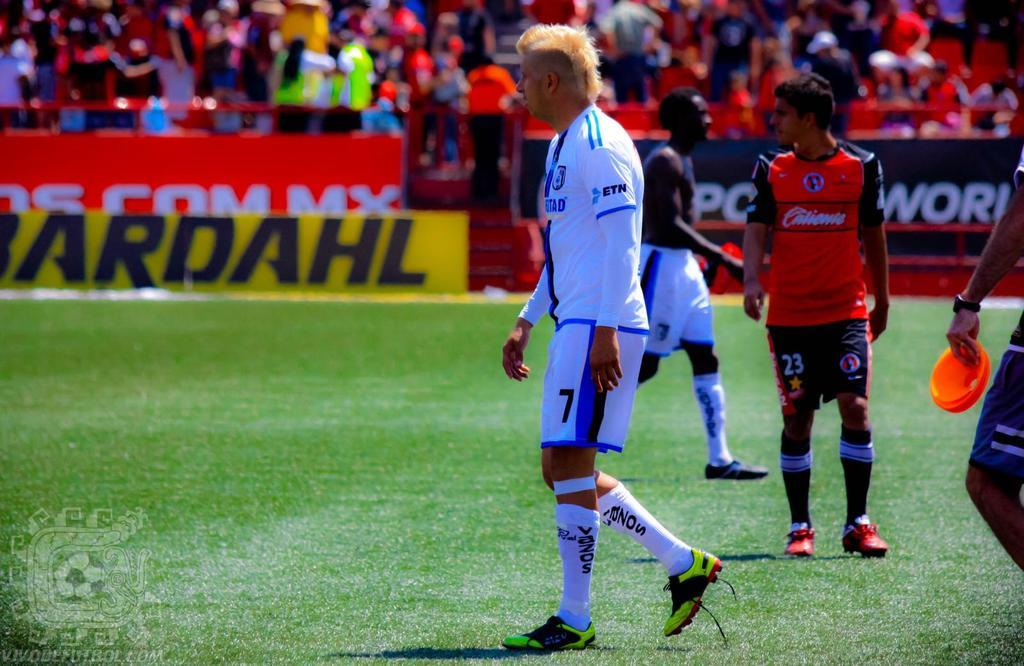<image>
Provide a brief description of the given image. Person wearing a white jersey that says ETN standing on a soccer field. 